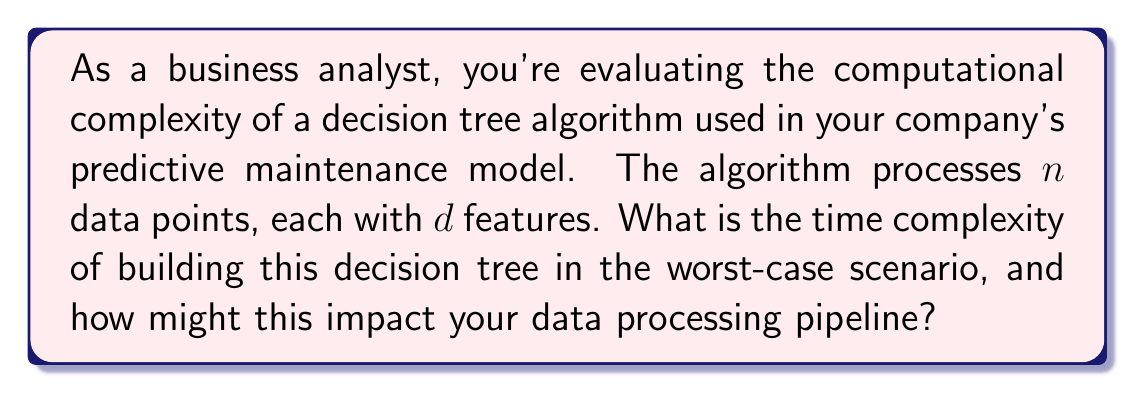Help me with this question. To understand the time complexity of building a decision tree, let's break down the process:

1. For each node in the tree:
   a. We need to evaluate all $n$ data points.
   b. For each data point, we consider all $d$ features.
   c. We need to find the best feature to split on, which requires sorting the data points for each feature.

2. In the worst-case scenario, the tree could be completely imbalanced, leading to a depth of $n$.

Let's analyze step by step:

1. Sorting $n$ elements takes $O(n \log n)$ time.
2. We do this for each of the $d$ features: $O(d \cdot n \log n)$.
3. We repeat this process for potentially $n$ levels in the worst case.

Therefore, the overall time complexity is:

$$ O(n \cdot d \cdot n \log n) = O(dn^2 \log n) $$

This complexity can significantly impact your data processing pipeline:

1. As the number of data points ($n$) increases, the processing time grows quadratically.
2. The number of features ($d$) linearly affects the complexity, so high-dimensional data will take longer to process.
3. For large datasets, this algorithm might become a bottleneck in your pipeline, potentially causing delays in data availability for analysis.

To mitigate these issues, you might consider:
1. Using more efficient decision tree algorithms (e.g., random forests).
2. Implementing feature selection techniques to reduce $d$.
3. Using distributed computing to parallelize the tree-building process.
Answer: The worst-case time complexity of building the decision tree is $O(dn^2 \log n)$, where $n$ is the number of data points and $d$ is the number of features. This quadratic growth with respect to the number of data points can significantly impact the data processing pipeline, potentially causing delays for large datasets. 